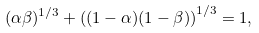<formula> <loc_0><loc_0><loc_500><loc_500>( \alpha \beta ) ^ { 1 / 3 } + \left ( ( 1 - \alpha ) ( 1 - \beta ) \right ) ^ { 1 / 3 } = 1 ,</formula> 